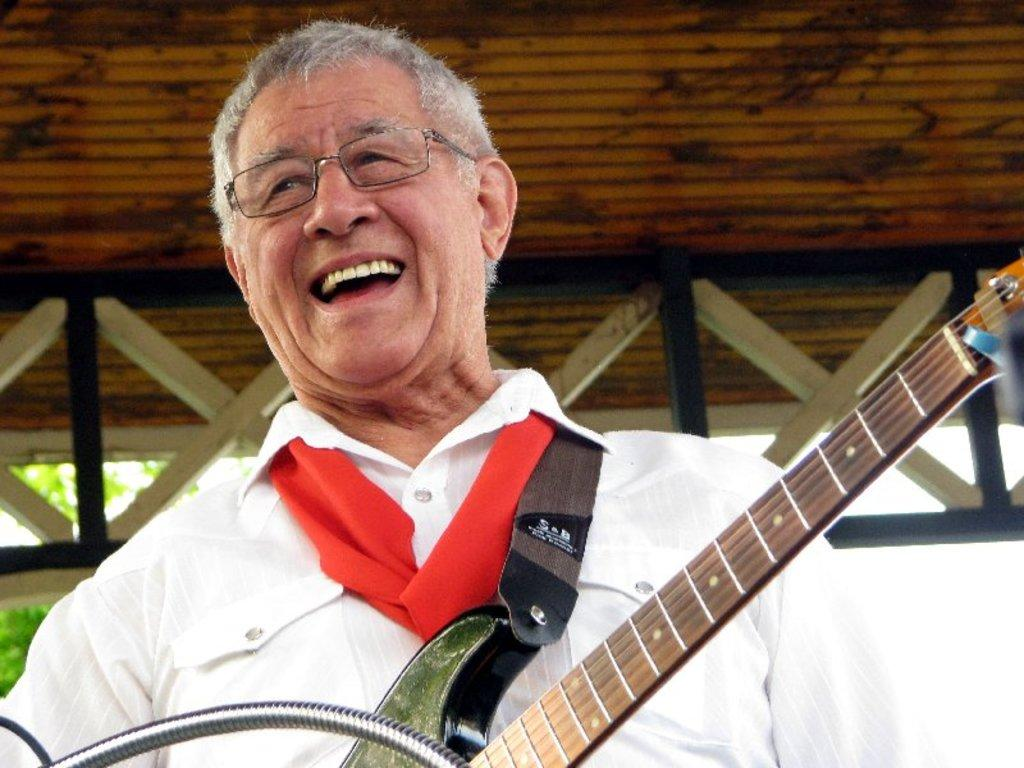What is the main subject of the image? The main subject of the image is a man. What is the man wearing in the image? The man is wearing a white shirt in the image. What activity is the man engaged in? The man is playing a guitar in the image. What can be seen in the background of the image? There is a tree in the background of the image. What type of cherry is hanging from the tree in the image? There is no cherry present in the image; the background only features a tree. Can you see a fan in the image? There is no fan visible in the image. 